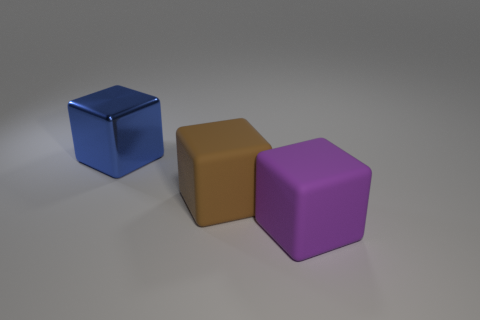How many things are cubes behind the big brown rubber cube or large green metallic blocks?
Keep it short and to the point. 1. What is the size of the brown block that is made of the same material as the purple block?
Provide a short and direct response. Large. How many big cubes have the same color as the big shiny thing?
Offer a terse response. 0. How many small things are purple things or brown blocks?
Offer a terse response. 0. Is there a large blue cube made of the same material as the brown object?
Your response must be concise. No. What is the block to the left of the brown matte thing made of?
Your answer should be very brief. Metal. There is a big matte object that is to the left of the large purple block; is it the same color as the thing left of the brown rubber block?
Ensure brevity in your answer.  No. The matte cube that is the same size as the brown matte object is what color?
Give a very brief answer. Purple. How many other things are there of the same shape as the purple object?
Offer a very short reply. 2. There is a brown matte thing on the left side of the large purple object; how big is it?
Make the answer very short. Large. 